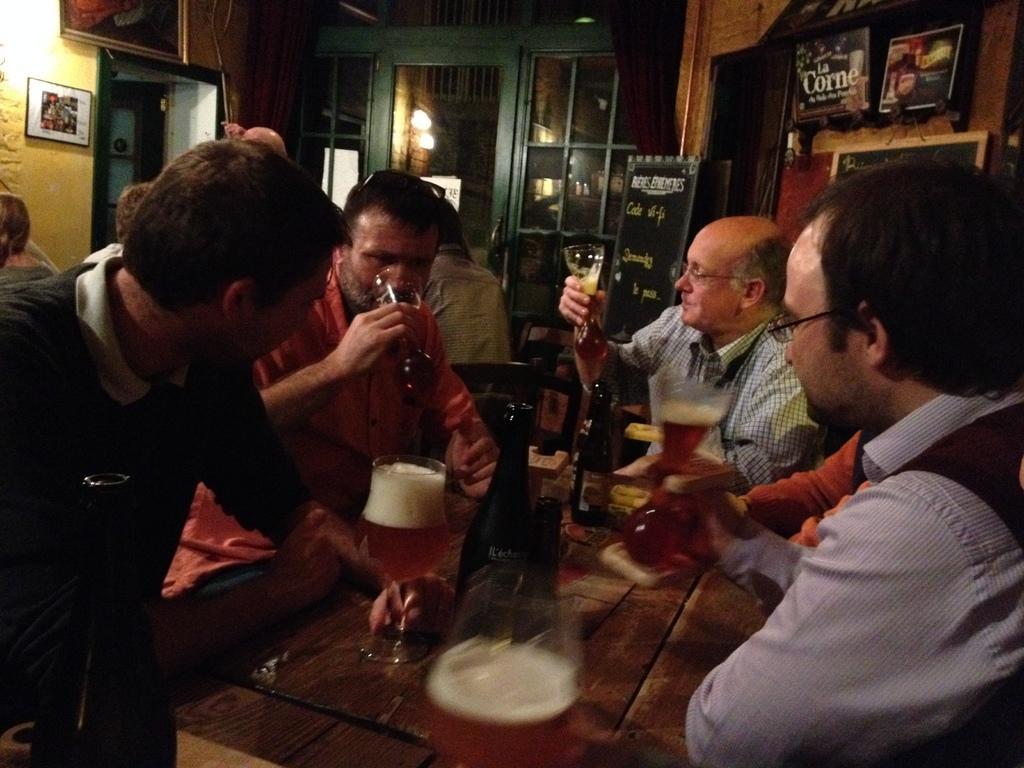Can you describe this image briefly? This image is taken inside a room. There are few persons in this room. In the left side of the image a person is sitting on a chair and holding a glass with wine on the table. In the right side of the image a man is holding a glass with wine in it. In the middle of the image there is a table on which there is a bottle of wine on it. At the background there is a wooden wall and lights and a photo frames to the wall. At the background there is a board with text on it. 